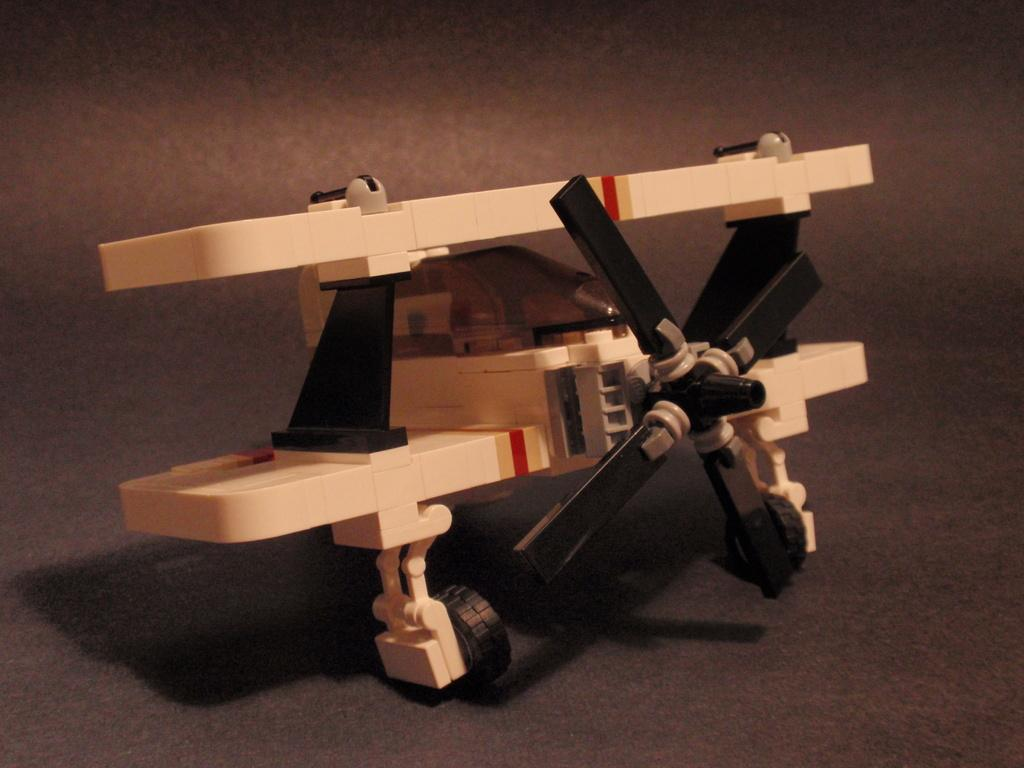What is the main subject of the image? The main subject of the image is a model of an aircraft. Can you describe the aircraft model in more detail? Unfortunately, the facts provided do not give any additional details about the aircraft model. Is there anything else in the image besides the aircraft model? The facts provided do not mention any other objects or subjects in the image. How many friends does the boy have in the image? There is no boy or friends present in the image; it only features a model of an aircraft. 